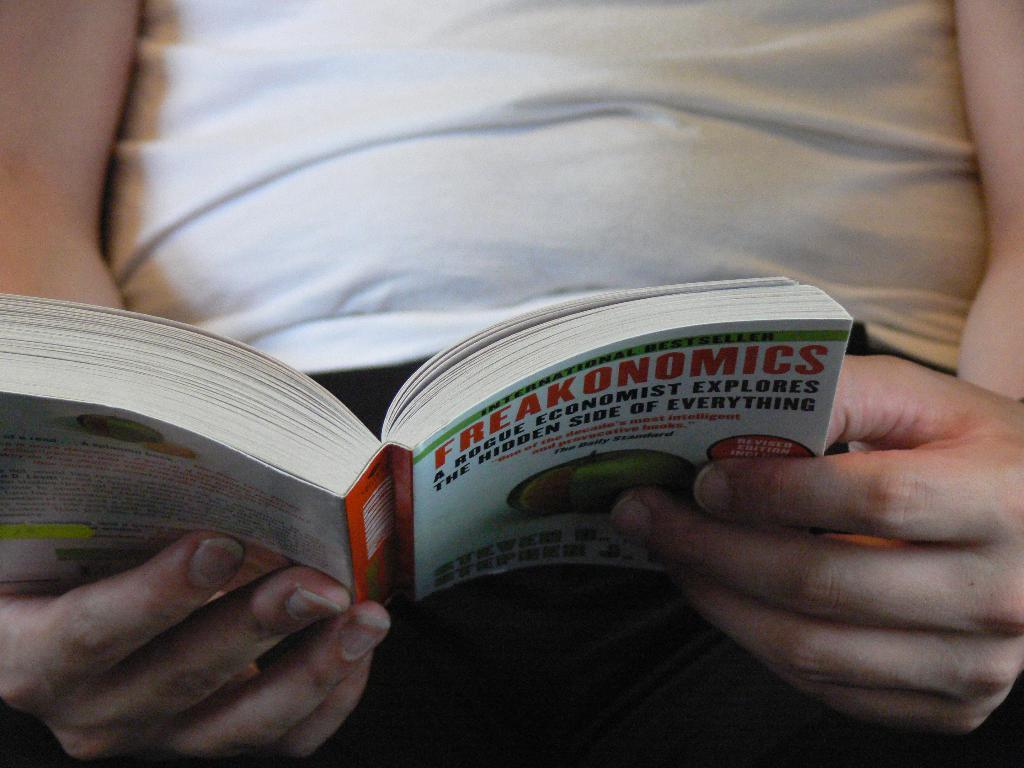<image>
Create a compact narrative representing the image presented. Man wearing a white shirt reading a book named Freakonomics. 